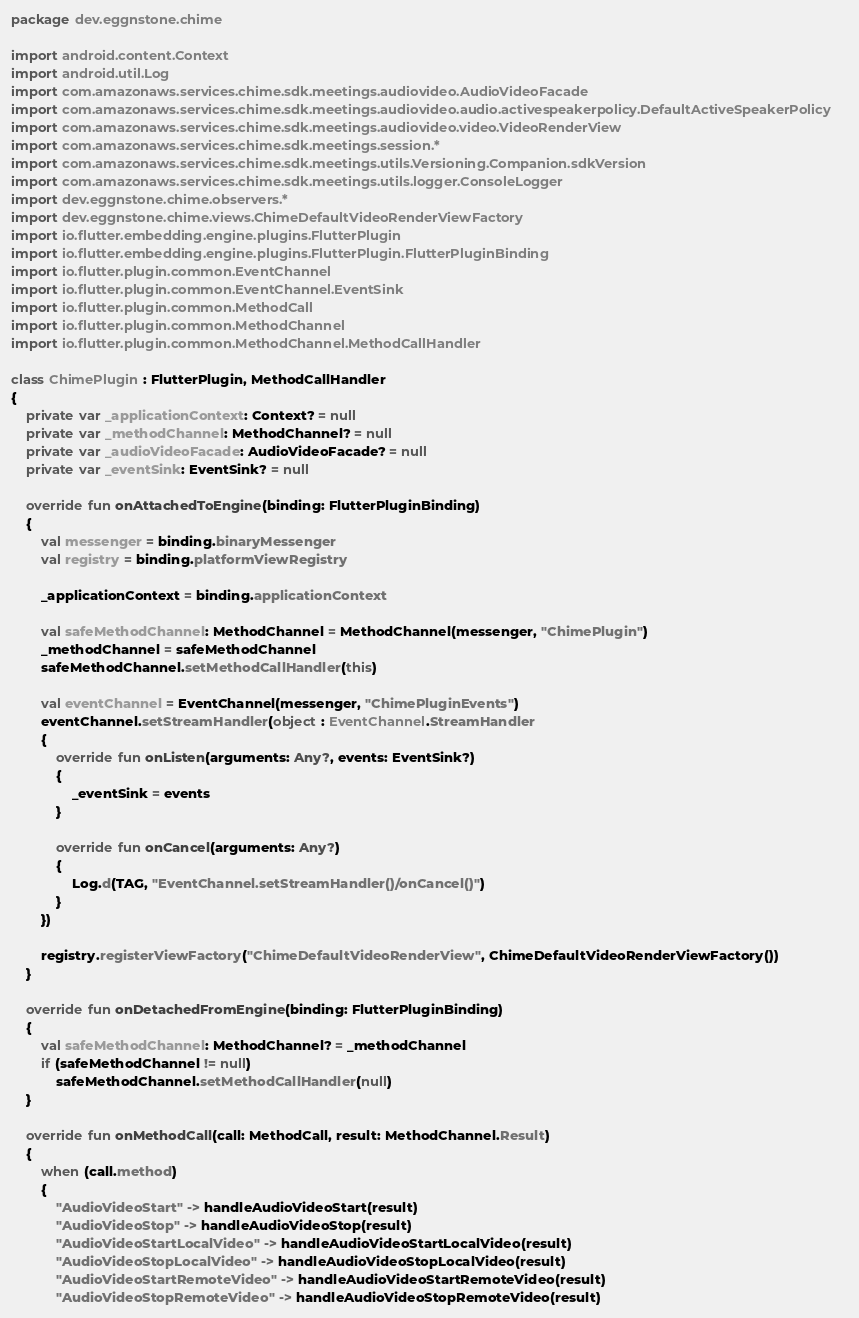Convert code to text. <code><loc_0><loc_0><loc_500><loc_500><_Kotlin_>package dev.eggnstone.chime

import android.content.Context
import android.util.Log
import com.amazonaws.services.chime.sdk.meetings.audiovideo.AudioVideoFacade
import com.amazonaws.services.chime.sdk.meetings.audiovideo.audio.activespeakerpolicy.DefaultActiveSpeakerPolicy
import com.amazonaws.services.chime.sdk.meetings.audiovideo.video.VideoRenderView
import com.amazonaws.services.chime.sdk.meetings.session.*
import com.amazonaws.services.chime.sdk.meetings.utils.Versioning.Companion.sdkVersion
import com.amazonaws.services.chime.sdk.meetings.utils.logger.ConsoleLogger
import dev.eggnstone.chime.observers.*
import dev.eggnstone.chime.views.ChimeDefaultVideoRenderViewFactory
import io.flutter.embedding.engine.plugins.FlutterPlugin
import io.flutter.embedding.engine.plugins.FlutterPlugin.FlutterPluginBinding
import io.flutter.plugin.common.EventChannel
import io.flutter.plugin.common.EventChannel.EventSink
import io.flutter.plugin.common.MethodCall
import io.flutter.plugin.common.MethodChannel
import io.flutter.plugin.common.MethodChannel.MethodCallHandler

class ChimePlugin : FlutterPlugin, MethodCallHandler
{
    private var _applicationContext: Context? = null
    private var _methodChannel: MethodChannel? = null
    private var _audioVideoFacade: AudioVideoFacade? = null
    private var _eventSink: EventSink? = null

    override fun onAttachedToEngine(binding: FlutterPluginBinding)
    {
        val messenger = binding.binaryMessenger
        val registry = binding.platformViewRegistry

        _applicationContext = binding.applicationContext

        val safeMethodChannel: MethodChannel = MethodChannel(messenger, "ChimePlugin")
        _methodChannel = safeMethodChannel
        safeMethodChannel.setMethodCallHandler(this)

        val eventChannel = EventChannel(messenger, "ChimePluginEvents")
        eventChannel.setStreamHandler(object : EventChannel.StreamHandler
        {
            override fun onListen(arguments: Any?, events: EventSink?)
            {
                _eventSink = events
            }

            override fun onCancel(arguments: Any?)
            {
                Log.d(TAG, "EventChannel.setStreamHandler()/onCancel()")
            }
        })

        registry.registerViewFactory("ChimeDefaultVideoRenderView", ChimeDefaultVideoRenderViewFactory())
    }

    override fun onDetachedFromEngine(binding: FlutterPluginBinding)
    {
        val safeMethodChannel: MethodChannel? = _methodChannel
        if (safeMethodChannel != null)
            safeMethodChannel.setMethodCallHandler(null)
    }

    override fun onMethodCall(call: MethodCall, result: MethodChannel.Result)
    {
        when (call.method)
        {
            "AudioVideoStart" -> handleAudioVideoStart(result)
            "AudioVideoStop" -> handleAudioVideoStop(result)
            "AudioVideoStartLocalVideo" -> handleAudioVideoStartLocalVideo(result)
            "AudioVideoStopLocalVideo" -> handleAudioVideoStopLocalVideo(result)
            "AudioVideoStartRemoteVideo" -> handleAudioVideoStartRemoteVideo(result)
            "AudioVideoStopRemoteVideo" -> handleAudioVideoStopRemoteVideo(result)</code> 